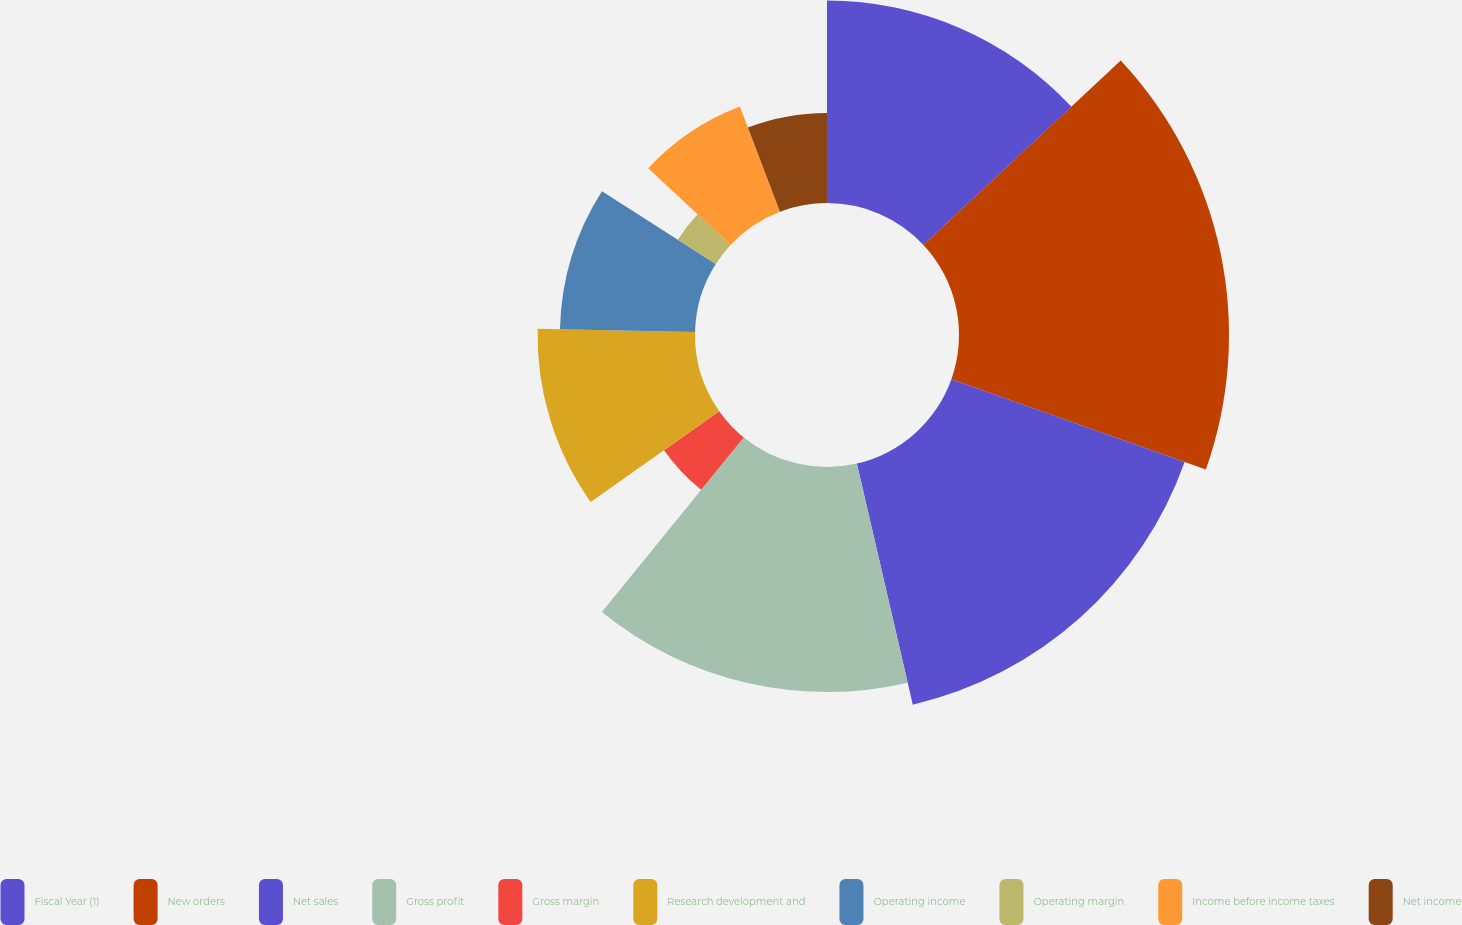<chart> <loc_0><loc_0><loc_500><loc_500><pie_chart><fcel>Fiscal Year (1)<fcel>New orders<fcel>Net sales<fcel>Gross profit<fcel>Gross margin<fcel>Research development and<fcel>Operating income<fcel>Operating margin<fcel>Income before income taxes<fcel>Net income<nl><fcel>13.04%<fcel>17.39%<fcel>15.94%<fcel>14.49%<fcel>4.35%<fcel>10.14%<fcel>8.7%<fcel>2.9%<fcel>7.25%<fcel>5.8%<nl></chart> 